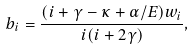<formula> <loc_0><loc_0><loc_500><loc_500>b _ { i } = \frac { ( i + \gamma - \kappa + \alpha / E ) w _ { i } } { i ( i + 2 \gamma ) } ,</formula> 